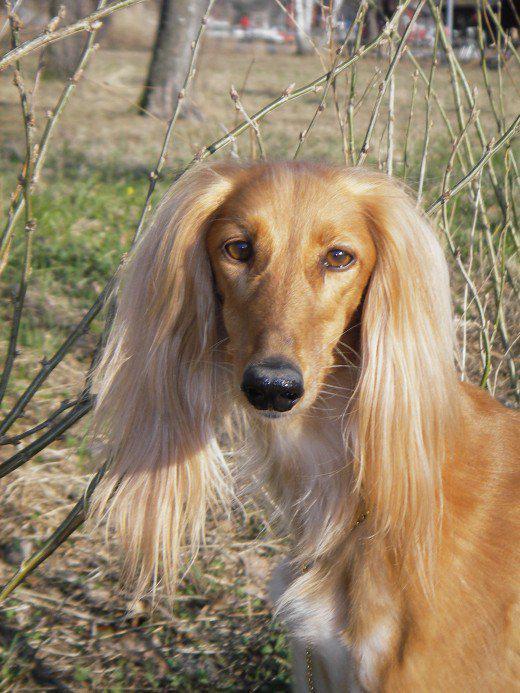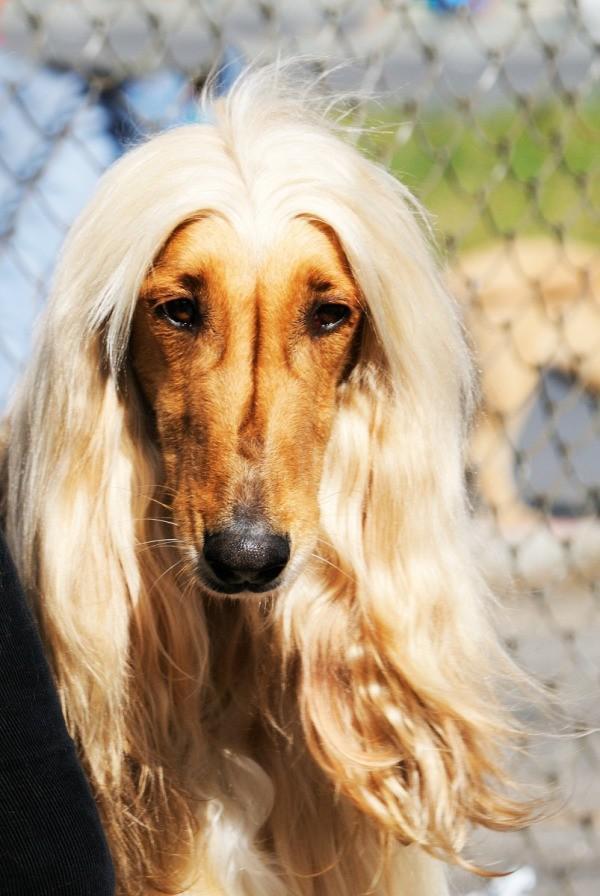The first image is the image on the left, the second image is the image on the right. For the images shown, is this caption "The hound on the right has reddish fur on its muzzle instead of a dark muzzle, and blonde hair on top of its head parted down the middle." true? Answer yes or no. Yes. 